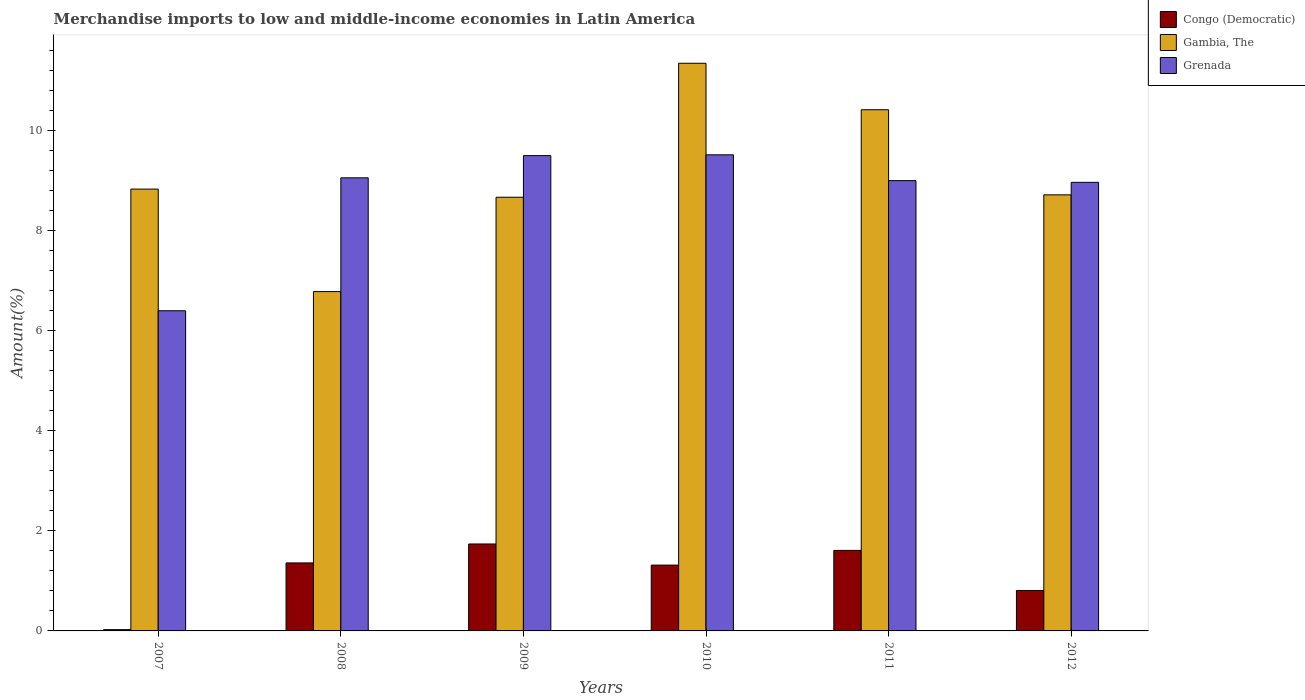Are the number of bars per tick equal to the number of legend labels?
Keep it short and to the point. Yes. Are the number of bars on each tick of the X-axis equal?
Make the answer very short. Yes. What is the label of the 5th group of bars from the left?
Provide a succinct answer. 2011. What is the percentage of amount earned from merchandise imports in Congo (Democratic) in 2009?
Provide a short and direct response. 1.74. Across all years, what is the maximum percentage of amount earned from merchandise imports in Congo (Democratic)?
Offer a very short reply. 1.74. Across all years, what is the minimum percentage of amount earned from merchandise imports in Congo (Democratic)?
Your answer should be compact. 0.03. In which year was the percentage of amount earned from merchandise imports in Gambia, The maximum?
Keep it short and to the point. 2010. In which year was the percentage of amount earned from merchandise imports in Congo (Democratic) minimum?
Give a very brief answer. 2007. What is the total percentage of amount earned from merchandise imports in Gambia, The in the graph?
Offer a terse response. 54.76. What is the difference between the percentage of amount earned from merchandise imports in Grenada in 2008 and that in 2012?
Provide a succinct answer. 0.09. What is the difference between the percentage of amount earned from merchandise imports in Congo (Democratic) in 2011 and the percentage of amount earned from merchandise imports in Grenada in 2010?
Give a very brief answer. -7.91. What is the average percentage of amount earned from merchandise imports in Congo (Democratic) per year?
Offer a very short reply. 1.14. In the year 2008, what is the difference between the percentage of amount earned from merchandise imports in Gambia, The and percentage of amount earned from merchandise imports in Grenada?
Your answer should be very brief. -2.27. What is the ratio of the percentage of amount earned from merchandise imports in Gambia, The in 2010 to that in 2012?
Offer a very short reply. 1.3. Is the difference between the percentage of amount earned from merchandise imports in Gambia, The in 2007 and 2011 greater than the difference between the percentage of amount earned from merchandise imports in Grenada in 2007 and 2011?
Provide a short and direct response. Yes. What is the difference between the highest and the second highest percentage of amount earned from merchandise imports in Gambia, The?
Ensure brevity in your answer.  0.93. What is the difference between the highest and the lowest percentage of amount earned from merchandise imports in Congo (Democratic)?
Give a very brief answer. 1.71. In how many years, is the percentage of amount earned from merchandise imports in Congo (Democratic) greater than the average percentage of amount earned from merchandise imports in Congo (Democratic) taken over all years?
Offer a terse response. 4. What does the 2nd bar from the left in 2007 represents?
Keep it short and to the point. Gambia, The. What does the 2nd bar from the right in 2011 represents?
Your answer should be very brief. Gambia, The. Is it the case that in every year, the sum of the percentage of amount earned from merchandise imports in Gambia, The and percentage of amount earned from merchandise imports in Grenada is greater than the percentage of amount earned from merchandise imports in Congo (Democratic)?
Keep it short and to the point. Yes. How many bars are there?
Offer a terse response. 18. How many years are there in the graph?
Provide a short and direct response. 6. What is the difference between two consecutive major ticks on the Y-axis?
Keep it short and to the point. 2. Are the values on the major ticks of Y-axis written in scientific E-notation?
Your answer should be very brief. No. How many legend labels are there?
Provide a short and direct response. 3. How are the legend labels stacked?
Your answer should be very brief. Vertical. What is the title of the graph?
Give a very brief answer. Merchandise imports to low and middle-income economies in Latin America. Does "Heavily indebted poor countries" appear as one of the legend labels in the graph?
Provide a short and direct response. No. What is the label or title of the X-axis?
Ensure brevity in your answer.  Years. What is the label or title of the Y-axis?
Keep it short and to the point. Amount(%). What is the Amount(%) of Congo (Democratic) in 2007?
Provide a short and direct response. 0.03. What is the Amount(%) of Gambia, The in 2007?
Offer a terse response. 8.83. What is the Amount(%) in Grenada in 2007?
Provide a short and direct response. 6.4. What is the Amount(%) in Congo (Democratic) in 2008?
Ensure brevity in your answer.  1.36. What is the Amount(%) in Gambia, The in 2008?
Your answer should be very brief. 6.78. What is the Amount(%) of Grenada in 2008?
Your answer should be very brief. 9.06. What is the Amount(%) of Congo (Democratic) in 2009?
Make the answer very short. 1.74. What is the Amount(%) in Gambia, The in 2009?
Your answer should be compact. 8.67. What is the Amount(%) of Grenada in 2009?
Offer a very short reply. 9.5. What is the Amount(%) in Congo (Democratic) in 2010?
Provide a succinct answer. 1.32. What is the Amount(%) in Gambia, The in 2010?
Give a very brief answer. 11.35. What is the Amount(%) in Grenada in 2010?
Keep it short and to the point. 9.52. What is the Amount(%) of Congo (Democratic) in 2011?
Ensure brevity in your answer.  1.61. What is the Amount(%) in Gambia, The in 2011?
Your answer should be compact. 10.42. What is the Amount(%) in Grenada in 2011?
Offer a terse response. 9. What is the Amount(%) in Congo (Democratic) in 2012?
Offer a very short reply. 0.81. What is the Amount(%) of Gambia, The in 2012?
Offer a terse response. 8.72. What is the Amount(%) in Grenada in 2012?
Make the answer very short. 8.97. Across all years, what is the maximum Amount(%) in Congo (Democratic)?
Offer a terse response. 1.74. Across all years, what is the maximum Amount(%) of Gambia, The?
Ensure brevity in your answer.  11.35. Across all years, what is the maximum Amount(%) of Grenada?
Provide a succinct answer. 9.52. Across all years, what is the minimum Amount(%) in Congo (Democratic)?
Your response must be concise. 0.03. Across all years, what is the minimum Amount(%) in Gambia, The?
Offer a very short reply. 6.78. Across all years, what is the minimum Amount(%) in Grenada?
Offer a terse response. 6.4. What is the total Amount(%) of Congo (Democratic) in the graph?
Ensure brevity in your answer.  6.86. What is the total Amount(%) in Gambia, The in the graph?
Keep it short and to the point. 54.76. What is the total Amount(%) in Grenada in the graph?
Your answer should be very brief. 52.44. What is the difference between the Amount(%) in Congo (Democratic) in 2007 and that in 2008?
Your answer should be compact. -1.33. What is the difference between the Amount(%) in Gambia, The in 2007 and that in 2008?
Provide a short and direct response. 2.05. What is the difference between the Amount(%) of Grenada in 2007 and that in 2008?
Offer a very short reply. -2.66. What is the difference between the Amount(%) in Congo (Democratic) in 2007 and that in 2009?
Offer a terse response. -1.71. What is the difference between the Amount(%) of Gambia, The in 2007 and that in 2009?
Provide a short and direct response. 0.16. What is the difference between the Amount(%) in Grenada in 2007 and that in 2009?
Offer a very short reply. -3.1. What is the difference between the Amount(%) in Congo (Democratic) in 2007 and that in 2010?
Ensure brevity in your answer.  -1.29. What is the difference between the Amount(%) of Gambia, The in 2007 and that in 2010?
Provide a succinct answer. -2.52. What is the difference between the Amount(%) in Grenada in 2007 and that in 2010?
Make the answer very short. -3.12. What is the difference between the Amount(%) of Congo (Democratic) in 2007 and that in 2011?
Your answer should be very brief. -1.58. What is the difference between the Amount(%) of Gambia, The in 2007 and that in 2011?
Your response must be concise. -1.59. What is the difference between the Amount(%) of Grenada in 2007 and that in 2011?
Offer a terse response. -2.6. What is the difference between the Amount(%) in Congo (Democratic) in 2007 and that in 2012?
Ensure brevity in your answer.  -0.78. What is the difference between the Amount(%) in Gambia, The in 2007 and that in 2012?
Make the answer very short. 0.12. What is the difference between the Amount(%) in Grenada in 2007 and that in 2012?
Your response must be concise. -2.57. What is the difference between the Amount(%) of Congo (Democratic) in 2008 and that in 2009?
Your answer should be compact. -0.38. What is the difference between the Amount(%) in Gambia, The in 2008 and that in 2009?
Offer a very short reply. -1.89. What is the difference between the Amount(%) of Grenada in 2008 and that in 2009?
Offer a terse response. -0.44. What is the difference between the Amount(%) of Congo (Democratic) in 2008 and that in 2010?
Give a very brief answer. 0.04. What is the difference between the Amount(%) in Gambia, The in 2008 and that in 2010?
Provide a succinct answer. -4.56. What is the difference between the Amount(%) of Grenada in 2008 and that in 2010?
Offer a very short reply. -0.46. What is the difference between the Amount(%) of Congo (Democratic) in 2008 and that in 2011?
Your answer should be very brief. -0.25. What is the difference between the Amount(%) in Gambia, The in 2008 and that in 2011?
Your response must be concise. -3.63. What is the difference between the Amount(%) of Grenada in 2008 and that in 2011?
Offer a very short reply. 0.06. What is the difference between the Amount(%) in Congo (Democratic) in 2008 and that in 2012?
Ensure brevity in your answer.  0.55. What is the difference between the Amount(%) of Gambia, The in 2008 and that in 2012?
Provide a short and direct response. -1.93. What is the difference between the Amount(%) in Grenada in 2008 and that in 2012?
Offer a very short reply. 0.09. What is the difference between the Amount(%) of Congo (Democratic) in 2009 and that in 2010?
Your answer should be compact. 0.42. What is the difference between the Amount(%) in Gambia, The in 2009 and that in 2010?
Provide a short and direct response. -2.68. What is the difference between the Amount(%) in Grenada in 2009 and that in 2010?
Give a very brief answer. -0.02. What is the difference between the Amount(%) in Congo (Democratic) in 2009 and that in 2011?
Provide a succinct answer. 0.13. What is the difference between the Amount(%) of Gambia, The in 2009 and that in 2011?
Your answer should be compact. -1.75. What is the difference between the Amount(%) in Grenada in 2009 and that in 2011?
Provide a succinct answer. 0.5. What is the difference between the Amount(%) in Congo (Democratic) in 2009 and that in 2012?
Offer a very short reply. 0.93. What is the difference between the Amount(%) in Gambia, The in 2009 and that in 2012?
Keep it short and to the point. -0.05. What is the difference between the Amount(%) of Grenada in 2009 and that in 2012?
Give a very brief answer. 0.53. What is the difference between the Amount(%) in Congo (Democratic) in 2010 and that in 2011?
Offer a very short reply. -0.29. What is the difference between the Amount(%) in Gambia, The in 2010 and that in 2011?
Your answer should be compact. 0.93. What is the difference between the Amount(%) in Grenada in 2010 and that in 2011?
Provide a succinct answer. 0.52. What is the difference between the Amount(%) in Congo (Democratic) in 2010 and that in 2012?
Keep it short and to the point. 0.51. What is the difference between the Amount(%) in Gambia, The in 2010 and that in 2012?
Your answer should be compact. 2.63. What is the difference between the Amount(%) of Grenada in 2010 and that in 2012?
Ensure brevity in your answer.  0.55. What is the difference between the Amount(%) of Congo (Democratic) in 2011 and that in 2012?
Your response must be concise. 0.8. What is the difference between the Amount(%) of Gambia, The in 2011 and that in 2012?
Your answer should be very brief. 1.7. What is the difference between the Amount(%) in Grenada in 2011 and that in 2012?
Provide a succinct answer. 0.03. What is the difference between the Amount(%) in Congo (Democratic) in 2007 and the Amount(%) in Gambia, The in 2008?
Offer a terse response. -6.76. What is the difference between the Amount(%) in Congo (Democratic) in 2007 and the Amount(%) in Grenada in 2008?
Provide a succinct answer. -9.03. What is the difference between the Amount(%) of Gambia, The in 2007 and the Amount(%) of Grenada in 2008?
Keep it short and to the point. -0.23. What is the difference between the Amount(%) in Congo (Democratic) in 2007 and the Amount(%) in Gambia, The in 2009?
Your answer should be very brief. -8.64. What is the difference between the Amount(%) in Congo (Democratic) in 2007 and the Amount(%) in Grenada in 2009?
Provide a succinct answer. -9.48. What is the difference between the Amount(%) of Gambia, The in 2007 and the Amount(%) of Grenada in 2009?
Your answer should be very brief. -0.67. What is the difference between the Amount(%) in Congo (Democratic) in 2007 and the Amount(%) in Gambia, The in 2010?
Provide a short and direct response. -11.32. What is the difference between the Amount(%) of Congo (Democratic) in 2007 and the Amount(%) of Grenada in 2010?
Your answer should be compact. -9.49. What is the difference between the Amount(%) in Gambia, The in 2007 and the Amount(%) in Grenada in 2010?
Your answer should be very brief. -0.69. What is the difference between the Amount(%) in Congo (Democratic) in 2007 and the Amount(%) in Gambia, The in 2011?
Provide a short and direct response. -10.39. What is the difference between the Amount(%) of Congo (Democratic) in 2007 and the Amount(%) of Grenada in 2011?
Offer a terse response. -8.98. What is the difference between the Amount(%) in Gambia, The in 2007 and the Amount(%) in Grenada in 2011?
Provide a short and direct response. -0.17. What is the difference between the Amount(%) in Congo (Democratic) in 2007 and the Amount(%) in Gambia, The in 2012?
Keep it short and to the point. -8.69. What is the difference between the Amount(%) in Congo (Democratic) in 2007 and the Amount(%) in Grenada in 2012?
Give a very brief answer. -8.94. What is the difference between the Amount(%) of Gambia, The in 2007 and the Amount(%) of Grenada in 2012?
Offer a terse response. -0.14. What is the difference between the Amount(%) in Congo (Democratic) in 2008 and the Amount(%) in Gambia, The in 2009?
Offer a very short reply. -7.31. What is the difference between the Amount(%) in Congo (Democratic) in 2008 and the Amount(%) in Grenada in 2009?
Offer a very short reply. -8.14. What is the difference between the Amount(%) of Gambia, The in 2008 and the Amount(%) of Grenada in 2009?
Offer a very short reply. -2.72. What is the difference between the Amount(%) of Congo (Democratic) in 2008 and the Amount(%) of Gambia, The in 2010?
Make the answer very short. -9.99. What is the difference between the Amount(%) of Congo (Democratic) in 2008 and the Amount(%) of Grenada in 2010?
Offer a very short reply. -8.16. What is the difference between the Amount(%) of Gambia, The in 2008 and the Amount(%) of Grenada in 2010?
Offer a terse response. -2.73. What is the difference between the Amount(%) in Congo (Democratic) in 2008 and the Amount(%) in Gambia, The in 2011?
Your answer should be very brief. -9.06. What is the difference between the Amount(%) in Congo (Democratic) in 2008 and the Amount(%) in Grenada in 2011?
Offer a very short reply. -7.64. What is the difference between the Amount(%) of Gambia, The in 2008 and the Amount(%) of Grenada in 2011?
Ensure brevity in your answer.  -2.22. What is the difference between the Amount(%) of Congo (Democratic) in 2008 and the Amount(%) of Gambia, The in 2012?
Give a very brief answer. -7.36. What is the difference between the Amount(%) in Congo (Democratic) in 2008 and the Amount(%) in Grenada in 2012?
Keep it short and to the point. -7.61. What is the difference between the Amount(%) of Gambia, The in 2008 and the Amount(%) of Grenada in 2012?
Make the answer very short. -2.18. What is the difference between the Amount(%) of Congo (Democratic) in 2009 and the Amount(%) of Gambia, The in 2010?
Offer a very short reply. -9.61. What is the difference between the Amount(%) of Congo (Democratic) in 2009 and the Amount(%) of Grenada in 2010?
Offer a very short reply. -7.78. What is the difference between the Amount(%) of Gambia, The in 2009 and the Amount(%) of Grenada in 2010?
Give a very brief answer. -0.85. What is the difference between the Amount(%) in Congo (Democratic) in 2009 and the Amount(%) in Gambia, The in 2011?
Your answer should be very brief. -8.68. What is the difference between the Amount(%) of Congo (Democratic) in 2009 and the Amount(%) of Grenada in 2011?
Your answer should be compact. -7.26. What is the difference between the Amount(%) of Gambia, The in 2009 and the Amount(%) of Grenada in 2011?
Ensure brevity in your answer.  -0.33. What is the difference between the Amount(%) of Congo (Democratic) in 2009 and the Amount(%) of Gambia, The in 2012?
Give a very brief answer. -6.98. What is the difference between the Amount(%) in Congo (Democratic) in 2009 and the Amount(%) in Grenada in 2012?
Make the answer very short. -7.23. What is the difference between the Amount(%) in Gambia, The in 2009 and the Amount(%) in Grenada in 2012?
Provide a succinct answer. -0.3. What is the difference between the Amount(%) in Congo (Democratic) in 2010 and the Amount(%) in Gambia, The in 2011?
Ensure brevity in your answer.  -9.1. What is the difference between the Amount(%) in Congo (Democratic) in 2010 and the Amount(%) in Grenada in 2011?
Your answer should be compact. -7.69. What is the difference between the Amount(%) of Gambia, The in 2010 and the Amount(%) of Grenada in 2011?
Provide a short and direct response. 2.35. What is the difference between the Amount(%) of Congo (Democratic) in 2010 and the Amount(%) of Gambia, The in 2012?
Offer a terse response. -7.4. What is the difference between the Amount(%) of Congo (Democratic) in 2010 and the Amount(%) of Grenada in 2012?
Ensure brevity in your answer.  -7.65. What is the difference between the Amount(%) in Gambia, The in 2010 and the Amount(%) in Grenada in 2012?
Provide a short and direct response. 2.38. What is the difference between the Amount(%) in Congo (Democratic) in 2011 and the Amount(%) in Gambia, The in 2012?
Provide a short and direct response. -7.11. What is the difference between the Amount(%) of Congo (Democratic) in 2011 and the Amount(%) of Grenada in 2012?
Provide a succinct answer. -7.36. What is the difference between the Amount(%) of Gambia, The in 2011 and the Amount(%) of Grenada in 2012?
Your answer should be very brief. 1.45. What is the average Amount(%) of Congo (Democratic) per year?
Make the answer very short. 1.14. What is the average Amount(%) in Gambia, The per year?
Offer a very short reply. 9.13. What is the average Amount(%) of Grenada per year?
Make the answer very short. 8.74. In the year 2007, what is the difference between the Amount(%) in Congo (Democratic) and Amount(%) in Gambia, The?
Ensure brevity in your answer.  -8.81. In the year 2007, what is the difference between the Amount(%) of Congo (Democratic) and Amount(%) of Grenada?
Ensure brevity in your answer.  -6.37. In the year 2007, what is the difference between the Amount(%) in Gambia, The and Amount(%) in Grenada?
Your answer should be compact. 2.43. In the year 2008, what is the difference between the Amount(%) of Congo (Democratic) and Amount(%) of Gambia, The?
Your answer should be very brief. -5.42. In the year 2008, what is the difference between the Amount(%) in Congo (Democratic) and Amount(%) in Grenada?
Offer a very short reply. -7.7. In the year 2008, what is the difference between the Amount(%) in Gambia, The and Amount(%) in Grenada?
Your answer should be very brief. -2.27. In the year 2009, what is the difference between the Amount(%) of Congo (Democratic) and Amount(%) of Gambia, The?
Give a very brief answer. -6.93. In the year 2009, what is the difference between the Amount(%) of Congo (Democratic) and Amount(%) of Grenada?
Provide a short and direct response. -7.76. In the year 2009, what is the difference between the Amount(%) in Gambia, The and Amount(%) in Grenada?
Ensure brevity in your answer.  -0.83. In the year 2010, what is the difference between the Amount(%) in Congo (Democratic) and Amount(%) in Gambia, The?
Make the answer very short. -10.03. In the year 2010, what is the difference between the Amount(%) of Congo (Democratic) and Amount(%) of Grenada?
Offer a very short reply. -8.2. In the year 2010, what is the difference between the Amount(%) of Gambia, The and Amount(%) of Grenada?
Make the answer very short. 1.83. In the year 2011, what is the difference between the Amount(%) in Congo (Democratic) and Amount(%) in Gambia, The?
Provide a short and direct response. -8.81. In the year 2011, what is the difference between the Amount(%) of Congo (Democratic) and Amount(%) of Grenada?
Offer a terse response. -7.39. In the year 2011, what is the difference between the Amount(%) in Gambia, The and Amount(%) in Grenada?
Your answer should be compact. 1.42. In the year 2012, what is the difference between the Amount(%) of Congo (Democratic) and Amount(%) of Gambia, The?
Offer a terse response. -7.91. In the year 2012, what is the difference between the Amount(%) of Congo (Democratic) and Amount(%) of Grenada?
Offer a terse response. -8.16. In the year 2012, what is the difference between the Amount(%) in Gambia, The and Amount(%) in Grenada?
Offer a terse response. -0.25. What is the ratio of the Amount(%) in Congo (Democratic) in 2007 to that in 2008?
Provide a short and direct response. 0.02. What is the ratio of the Amount(%) of Gambia, The in 2007 to that in 2008?
Offer a very short reply. 1.3. What is the ratio of the Amount(%) of Grenada in 2007 to that in 2008?
Your answer should be compact. 0.71. What is the ratio of the Amount(%) of Congo (Democratic) in 2007 to that in 2009?
Give a very brief answer. 0.01. What is the ratio of the Amount(%) of Gambia, The in 2007 to that in 2009?
Give a very brief answer. 1.02. What is the ratio of the Amount(%) of Grenada in 2007 to that in 2009?
Give a very brief answer. 0.67. What is the ratio of the Amount(%) of Congo (Democratic) in 2007 to that in 2010?
Provide a succinct answer. 0.02. What is the ratio of the Amount(%) of Gambia, The in 2007 to that in 2010?
Your answer should be very brief. 0.78. What is the ratio of the Amount(%) of Grenada in 2007 to that in 2010?
Offer a terse response. 0.67. What is the ratio of the Amount(%) in Congo (Democratic) in 2007 to that in 2011?
Provide a short and direct response. 0.02. What is the ratio of the Amount(%) of Gambia, The in 2007 to that in 2011?
Ensure brevity in your answer.  0.85. What is the ratio of the Amount(%) in Grenada in 2007 to that in 2011?
Offer a very short reply. 0.71. What is the ratio of the Amount(%) in Congo (Democratic) in 2007 to that in 2012?
Your response must be concise. 0.03. What is the ratio of the Amount(%) in Gambia, The in 2007 to that in 2012?
Keep it short and to the point. 1.01. What is the ratio of the Amount(%) of Grenada in 2007 to that in 2012?
Your answer should be very brief. 0.71. What is the ratio of the Amount(%) of Congo (Democratic) in 2008 to that in 2009?
Make the answer very short. 0.78. What is the ratio of the Amount(%) in Gambia, The in 2008 to that in 2009?
Your answer should be very brief. 0.78. What is the ratio of the Amount(%) of Grenada in 2008 to that in 2009?
Keep it short and to the point. 0.95. What is the ratio of the Amount(%) of Congo (Democratic) in 2008 to that in 2010?
Keep it short and to the point. 1.03. What is the ratio of the Amount(%) in Gambia, The in 2008 to that in 2010?
Your answer should be very brief. 0.6. What is the ratio of the Amount(%) of Grenada in 2008 to that in 2010?
Provide a succinct answer. 0.95. What is the ratio of the Amount(%) in Congo (Democratic) in 2008 to that in 2011?
Give a very brief answer. 0.84. What is the ratio of the Amount(%) in Gambia, The in 2008 to that in 2011?
Your response must be concise. 0.65. What is the ratio of the Amount(%) in Grenada in 2008 to that in 2011?
Ensure brevity in your answer.  1.01. What is the ratio of the Amount(%) of Congo (Democratic) in 2008 to that in 2012?
Keep it short and to the point. 1.68. What is the ratio of the Amount(%) in Gambia, The in 2008 to that in 2012?
Provide a succinct answer. 0.78. What is the ratio of the Amount(%) in Grenada in 2008 to that in 2012?
Your answer should be compact. 1.01. What is the ratio of the Amount(%) in Congo (Democratic) in 2009 to that in 2010?
Your answer should be compact. 1.32. What is the ratio of the Amount(%) of Gambia, The in 2009 to that in 2010?
Provide a succinct answer. 0.76. What is the ratio of the Amount(%) in Grenada in 2009 to that in 2010?
Ensure brevity in your answer.  1. What is the ratio of the Amount(%) in Congo (Democratic) in 2009 to that in 2011?
Keep it short and to the point. 1.08. What is the ratio of the Amount(%) of Gambia, The in 2009 to that in 2011?
Offer a very short reply. 0.83. What is the ratio of the Amount(%) in Grenada in 2009 to that in 2011?
Your response must be concise. 1.06. What is the ratio of the Amount(%) of Congo (Democratic) in 2009 to that in 2012?
Ensure brevity in your answer.  2.15. What is the ratio of the Amount(%) of Grenada in 2009 to that in 2012?
Keep it short and to the point. 1.06. What is the ratio of the Amount(%) in Congo (Democratic) in 2010 to that in 2011?
Ensure brevity in your answer.  0.82. What is the ratio of the Amount(%) of Gambia, The in 2010 to that in 2011?
Your response must be concise. 1.09. What is the ratio of the Amount(%) of Grenada in 2010 to that in 2011?
Offer a very short reply. 1.06. What is the ratio of the Amount(%) of Congo (Democratic) in 2010 to that in 2012?
Your response must be concise. 1.63. What is the ratio of the Amount(%) in Gambia, The in 2010 to that in 2012?
Your answer should be compact. 1.3. What is the ratio of the Amount(%) in Grenada in 2010 to that in 2012?
Your answer should be compact. 1.06. What is the ratio of the Amount(%) of Congo (Democratic) in 2011 to that in 2012?
Your answer should be very brief. 1.99. What is the ratio of the Amount(%) of Gambia, The in 2011 to that in 2012?
Provide a short and direct response. 1.2. What is the difference between the highest and the second highest Amount(%) in Congo (Democratic)?
Your answer should be compact. 0.13. What is the difference between the highest and the second highest Amount(%) in Gambia, The?
Keep it short and to the point. 0.93. What is the difference between the highest and the second highest Amount(%) in Grenada?
Your response must be concise. 0.02. What is the difference between the highest and the lowest Amount(%) in Congo (Democratic)?
Keep it short and to the point. 1.71. What is the difference between the highest and the lowest Amount(%) of Gambia, The?
Your response must be concise. 4.56. What is the difference between the highest and the lowest Amount(%) in Grenada?
Provide a short and direct response. 3.12. 